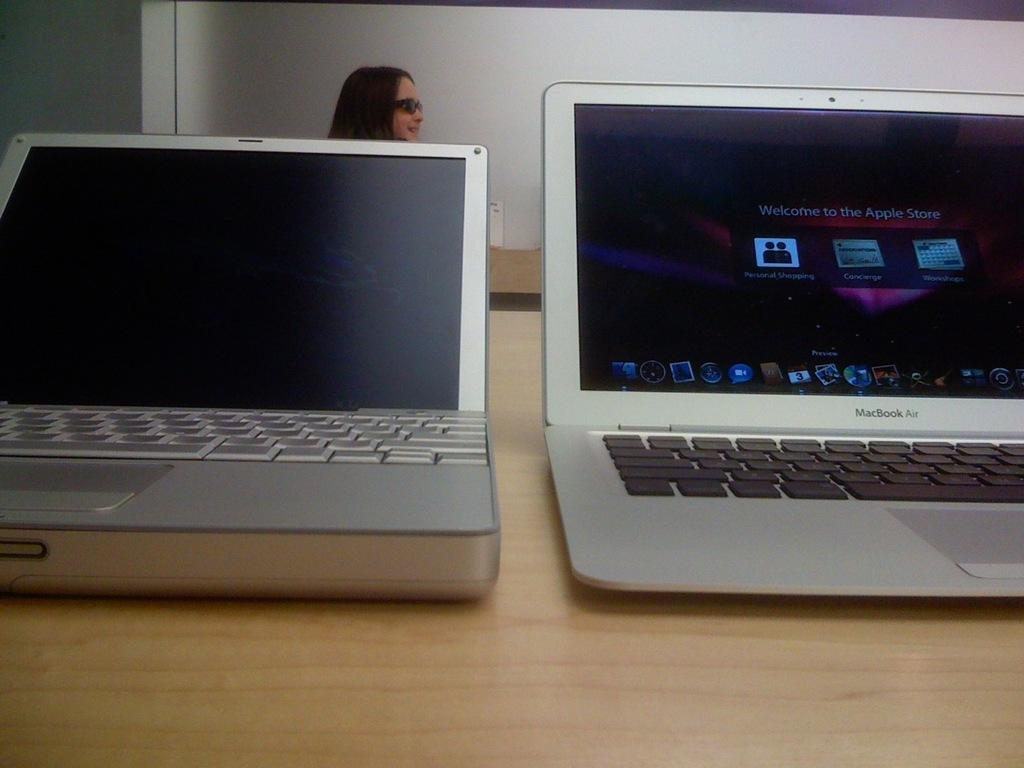<image>
Describe the image concisely. Two laptop computers one of which is macbook air sits on a table. 